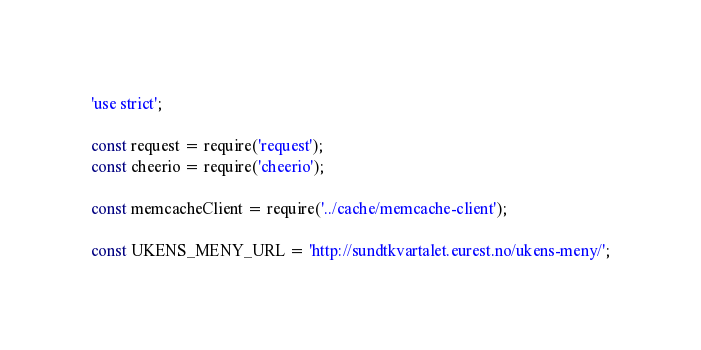<code> <loc_0><loc_0><loc_500><loc_500><_JavaScript_>'use strict';

const request = require('request');
const cheerio = require('cheerio');

const memcacheClient = require('../cache/memcache-client');

const UKENS_MENY_URL = 'http://sundtkvartalet.eurest.no/ukens-meny/';</code> 